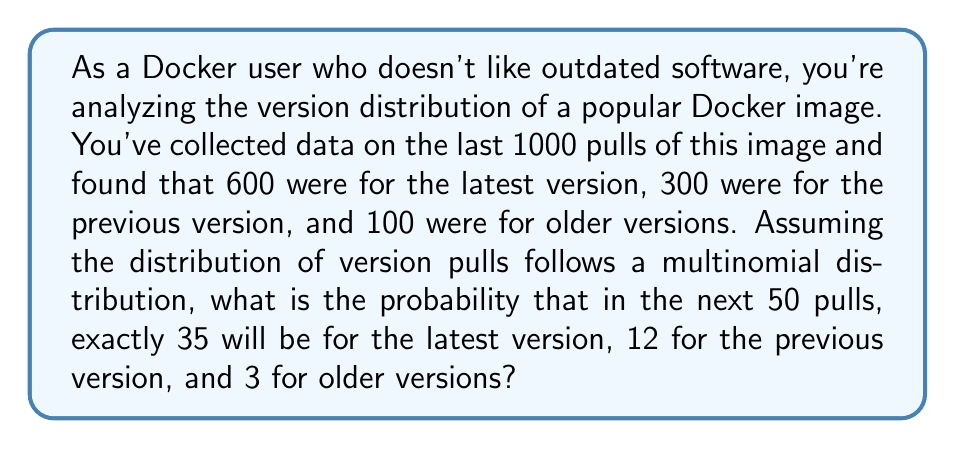Can you solve this math problem? To solve this problem, we'll use the multinomial probability mass function:

$$P(X_1 = x_1, X_2 = x_2, ..., X_k = x_k) = \frac{n!}{x_1! x_2! ... x_k!} p_1^{x_1} p_2^{x_2} ... p_k^{x_k}$$

Where:
- $n$ is the total number of trials (pulls)
- $x_i$ is the number of occurrences of each outcome
- $p_i$ is the probability of each outcome

Step 1: Calculate the probabilities for each version:
$p_1 = 600/1000 = 0.6$ (latest version)
$p_2 = 300/1000 = 0.3$ (previous version)
$p_3 = 100/1000 = 0.1$ (older versions)

Step 2: Plug the values into the multinomial probability mass function:

$$P(X_1 = 35, X_2 = 12, X_3 = 3) = \frac{50!}{35! 12! 3!} (0.6)^{35} (0.3)^{12} (0.1)^3$$

Step 3: Calculate the result:

$$\begin{align*}
&= \frac{50!}{35! 12! 3!} \times (0.6)^{35} \times (0.3)^{12} \times (0.1)^3 \\
&\approx 2.25414 \times 10^{62} \times 1.54019 \times 10^{-15} \times 5.31441 \times 10^{-7} \times 1 \times 10^{-3} \\
&\approx 0.0827
\end{align*}$$
Answer: The probability of exactly 35 pulls for the latest version, 12 for the previous version, and 3 for older versions in the next 50 pulls is approximately 0.0827 or 8.27%. 